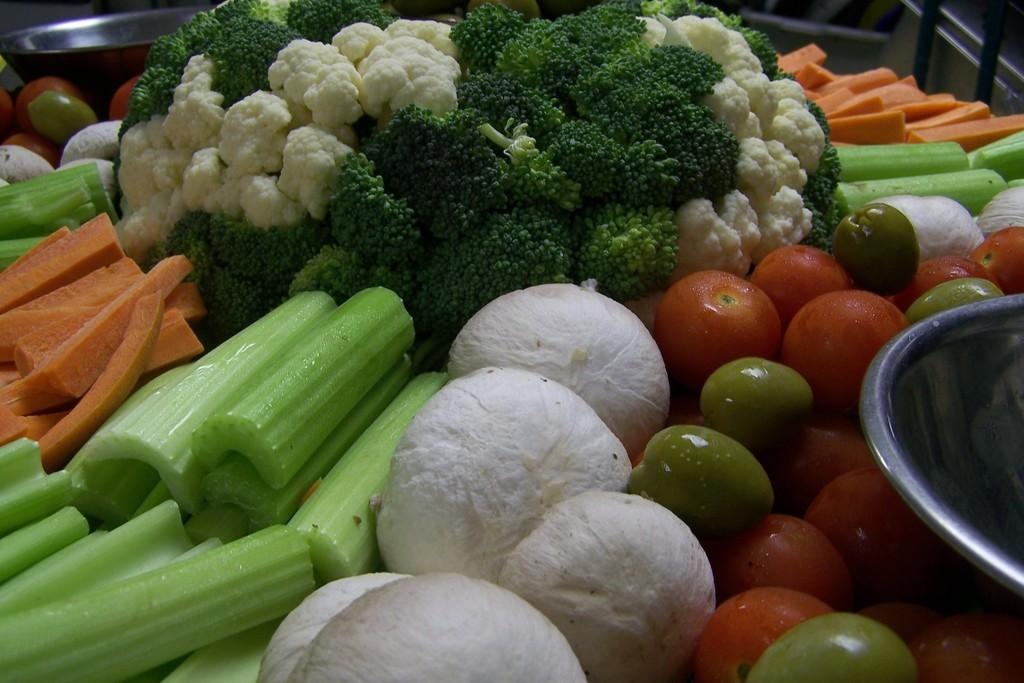What vegetables can be seen in the image? There are carrots, cauliflower, and tomatoes in the image. Are there any other vegetables present in the image besides these three? Yes, there are other unspecified vegetables in the image. What is used to hold or serve the vegetables in the image? There is a bowl in the image. How many eyes can be seen on the vegetables in the image? There are no eyes visible on the vegetables in the image, as vegetables do not have eyes. 